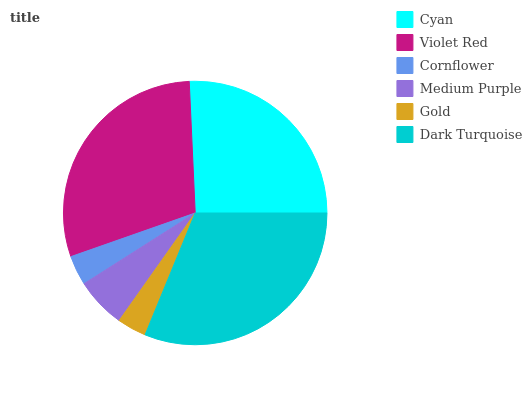Is Gold the minimum?
Answer yes or no. Yes. Is Dark Turquoise the maximum?
Answer yes or no. Yes. Is Violet Red the minimum?
Answer yes or no. No. Is Violet Red the maximum?
Answer yes or no. No. Is Violet Red greater than Cyan?
Answer yes or no. Yes. Is Cyan less than Violet Red?
Answer yes or no. Yes. Is Cyan greater than Violet Red?
Answer yes or no. No. Is Violet Red less than Cyan?
Answer yes or no. No. Is Cyan the high median?
Answer yes or no. Yes. Is Medium Purple the low median?
Answer yes or no. Yes. Is Medium Purple the high median?
Answer yes or no. No. Is Cornflower the low median?
Answer yes or no. No. 